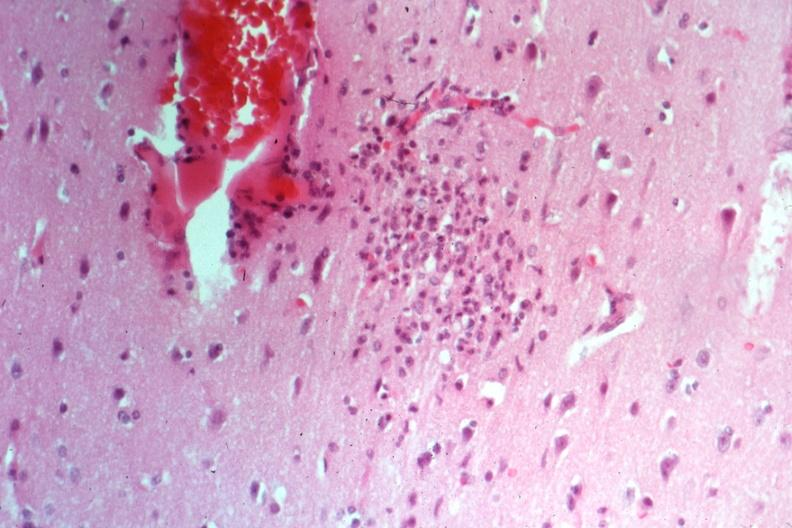does feet show typical nodule cause not known at this time?
Answer the question using a single word or phrase. No 